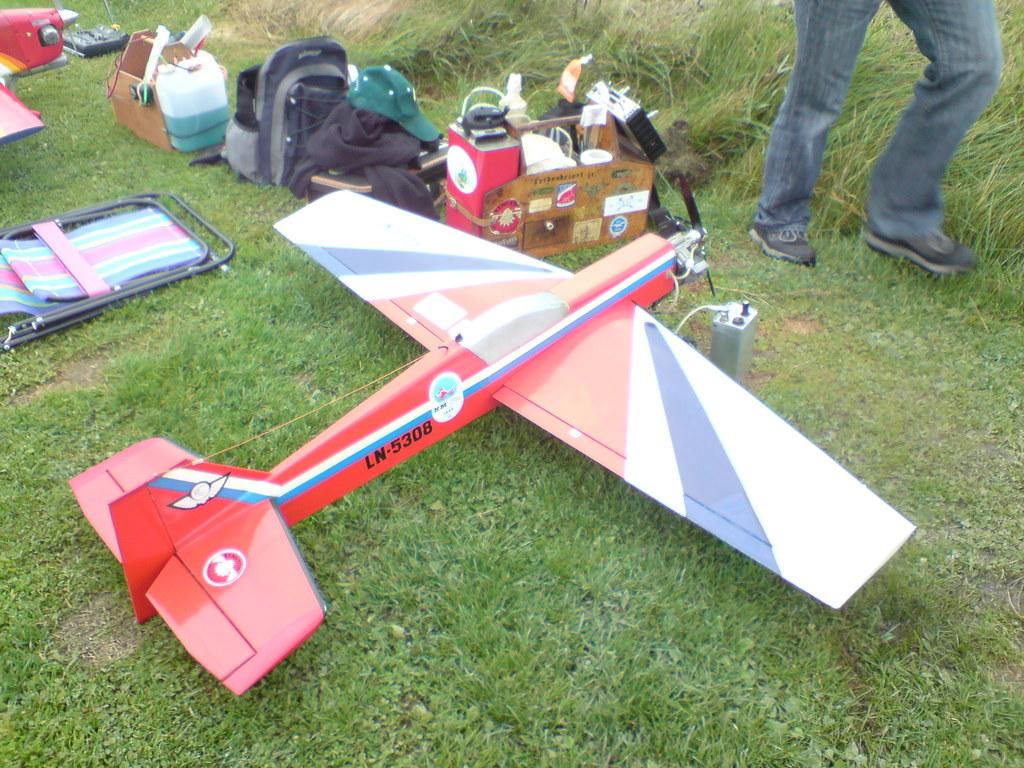What's the flight number?
Your answer should be compact. Ln-5308. 